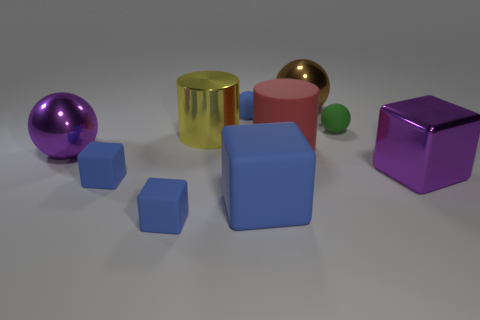Subtract all large purple metal spheres. How many spheres are left? 3 Subtract all blue cubes. How many cubes are left? 1 Subtract all blocks. How many objects are left? 6 Subtract 2 spheres. How many spheres are left? 2 Subtract all blue cylinders. Subtract all red blocks. How many cylinders are left? 2 Subtract all yellow spheres. How many cyan cylinders are left? 0 Subtract all big cyan cylinders. Subtract all large objects. How many objects are left? 4 Add 6 yellow objects. How many yellow objects are left? 7 Add 3 yellow shiny objects. How many yellow shiny objects exist? 4 Subtract 0 green blocks. How many objects are left? 10 